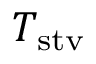Convert formula to latex. <formula><loc_0><loc_0><loc_500><loc_500>T _ { s t v }</formula> 